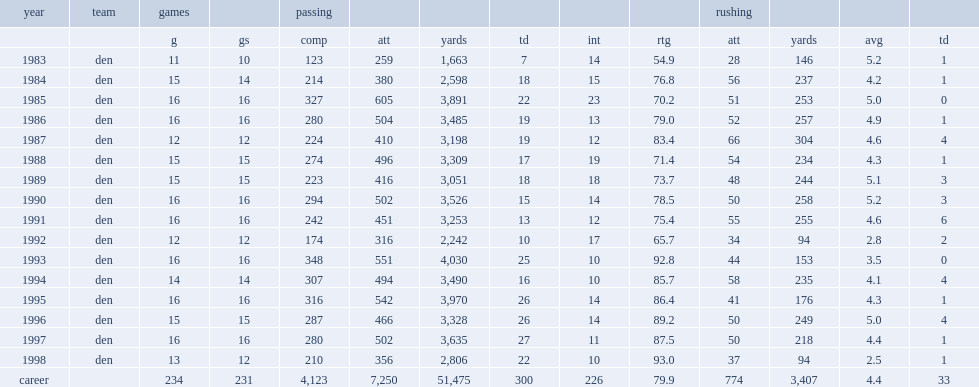How many rushing yards did john elway have? 3407.0. 